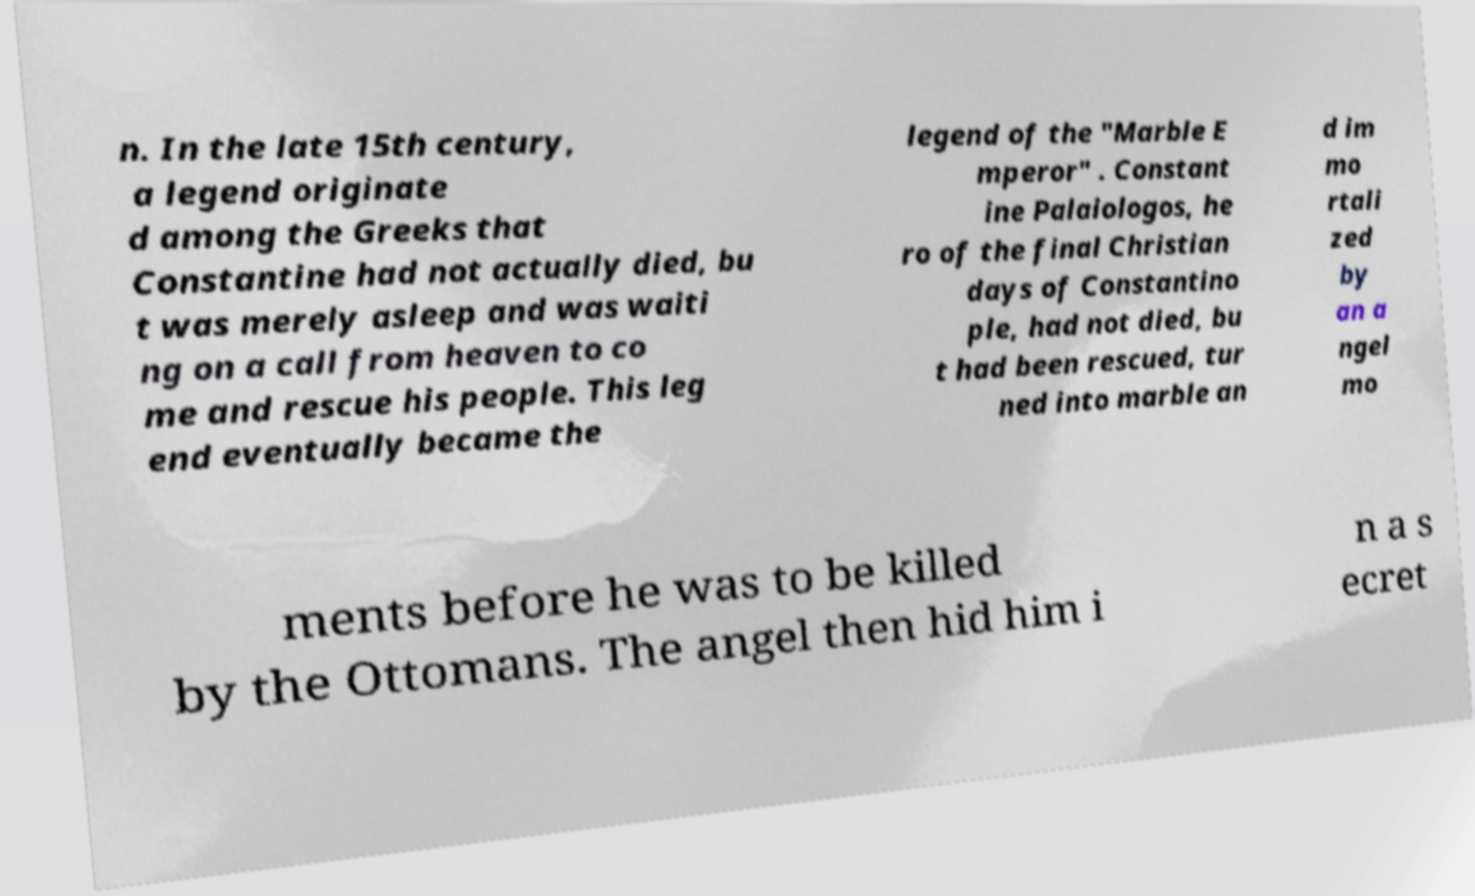Can you read and provide the text displayed in the image?This photo seems to have some interesting text. Can you extract and type it out for me? n. In the late 15th century, a legend originate d among the Greeks that Constantine had not actually died, bu t was merely asleep and was waiti ng on a call from heaven to co me and rescue his people. This leg end eventually became the legend of the "Marble E mperor" . Constant ine Palaiologos, he ro of the final Christian days of Constantino ple, had not died, bu t had been rescued, tur ned into marble an d im mo rtali zed by an a ngel mo ments before he was to be killed by the Ottomans. The angel then hid him i n a s ecret 